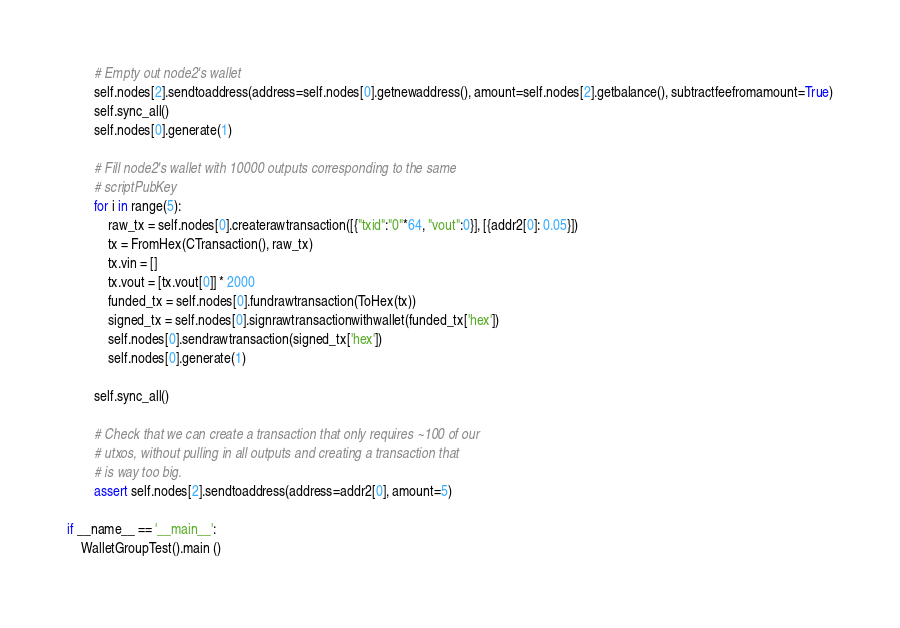Convert code to text. <code><loc_0><loc_0><loc_500><loc_500><_Python_>
        # Empty out node2's wallet
        self.nodes[2].sendtoaddress(address=self.nodes[0].getnewaddress(), amount=self.nodes[2].getbalance(), subtractfeefromamount=True)
        self.sync_all()
        self.nodes[0].generate(1)

        # Fill node2's wallet with 10000 outputs corresponding to the same
        # scriptPubKey
        for i in range(5):
            raw_tx = self.nodes[0].createrawtransaction([{"txid":"0"*64, "vout":0}], [{addr2[0]: 0.05}])
            tx = FromHex(CTransaction(), raw_tx)
            tx.vin = []
            tx.vout = [tx.vout[0]] * 2000
            funded_tx = self.nodes[0].fundrawtransaction(ToHex(tx))
            signed_tx = self.nodes[0].signrawtransactionwithwallet(funded_tx['hex'])
            self.nodes[0].sendrawtransaction(signed_tx['hex'])
            self.nodes[0].generate(1)

        self.sync_all()

        # Check that we can create a transaction that only requires ~100 of our
        # utxos, without pulling in all outputs and creating a transaction that
        # is way too big.
        assert self.nodes[2].sendtoaddress(address=addr2[0], amount=5)

if __name__ == '__main__':
    WalletGroupTest().main ()
</code> 